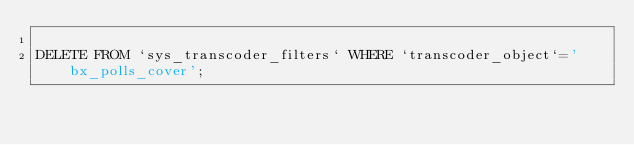<code> <loc_0><loc_0><loc_500><loc_500><_SQL_>
DELETE FROM `sys_transcoder_filters` WHERE `transcoder_object`='bx_polls_cover';</code> 